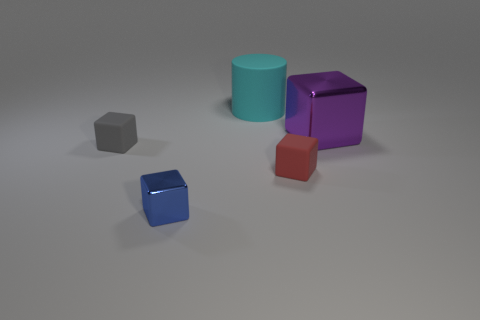Add 1 big purple metal things. How many objects exist? 6 Subtract all cubes. How many objects are left? 1 Subtract 0 blue balls. How many objects are left? 5 Subtract all red rubber blocks. Subtract all tiny blocks. How many objects are left? 1 Add 3 metallic blocks. How many metallic blocks are left? 5 Add 4 tiny green rubber cylinders. How many tiny green rubber cylinders exist? 4 